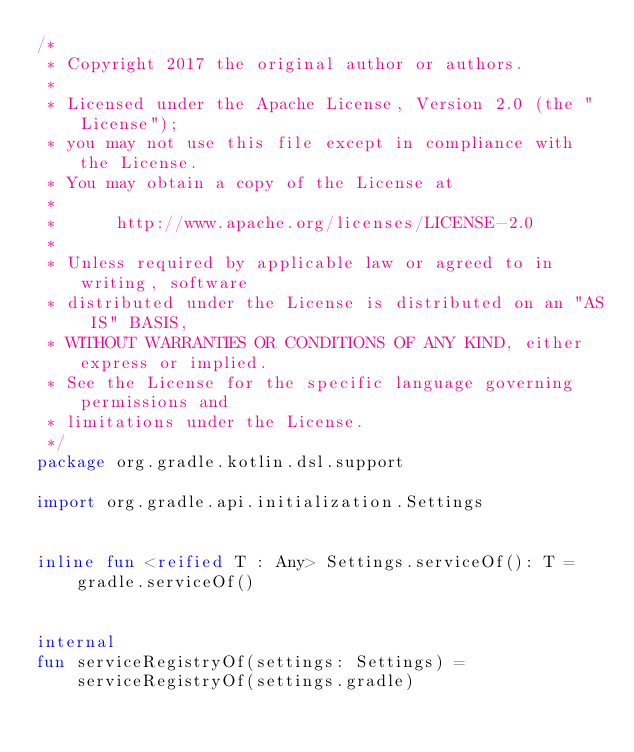<code> <loc_0><loc_0><loc_500><loc_500><_Kotlin_>/*
 * Copyright 2017 the original author or authors.
 *
 * Licensed under the Apache License, Version 2.0 (the "License");
 * you may not use this file except in compliance with the License.
 * You may obtain a copy of the License at
 *
 *      http://www.apache.org/licenses/LICENSE-2.0
 *
 * Unless required by applicable law or agreed to in writing, software
 * distributed under the License is distributed on an "AS IS" BASIS,
 * WITHOUT WARRANTIES OR CONDITIONS OF ANY KIND, either express or implied.
 * See the License for the specific language governing permissions and
 * limitations under the License.
 */
package org.gradle.kotlin.dsl.support

import org.gradle.api.initialization.Settings


inline fun <reified T : Any> Settings.serviceOf(): T =
    gradle.serviceOf()


internal
fun serviceRegistryOf(settings: Settings) =
    serviceRegistryOf(settings.gradle)
</code> 